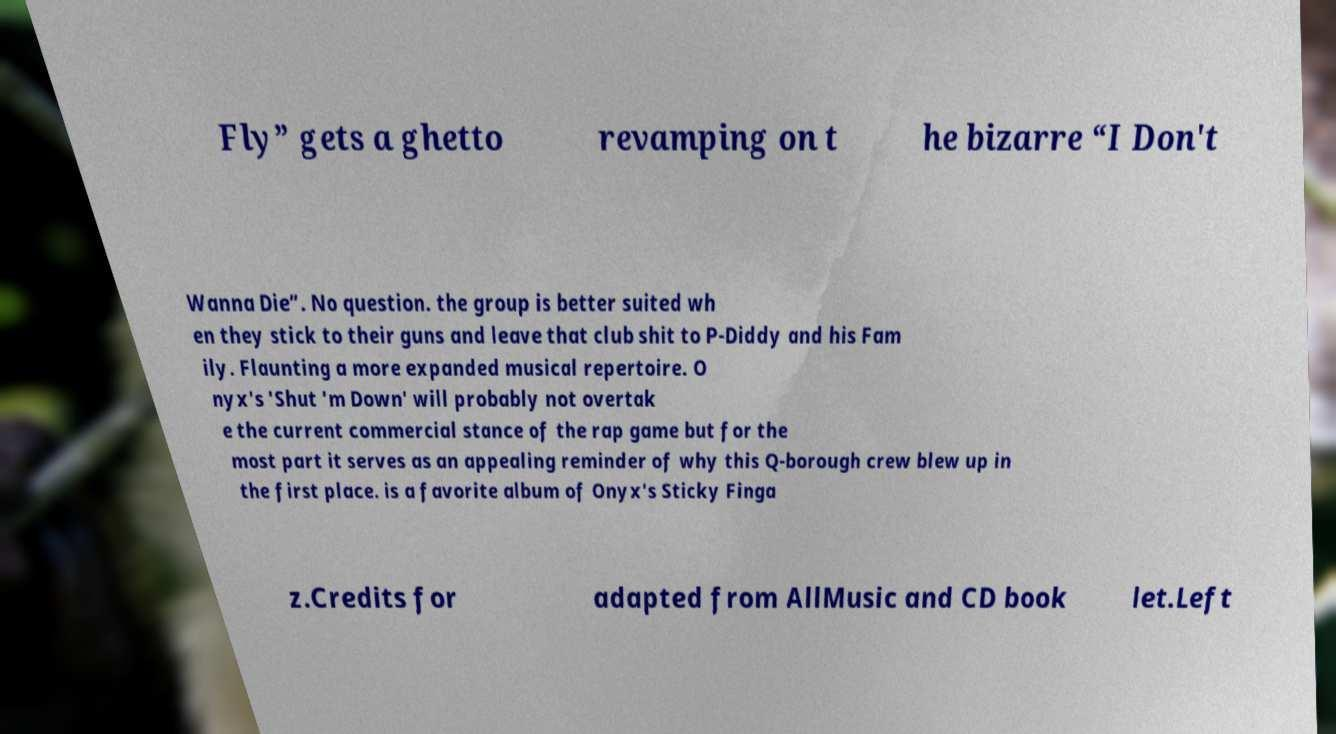I need the written content from this picture converted into text. Can you do that? Fly” gets a ghetto revamping on t he bizarre “I Don't Wanna Die”. No question. the group is better suited wh en they stick to their guns and leave that club shit to P-Diddy and his Fam ily. Flaunting a more expanded musical repertoire. O nyx's 'Shut 'm Down' will probably not overtak e the current commercial stance of the rap game but for the most part it serves as an appealing reminder of why this Q-borough crew blew up in the first place. is a favorite album of Onyx's Sticky Finga z.Credits for adapted from AllMusic and CD book let.Left 